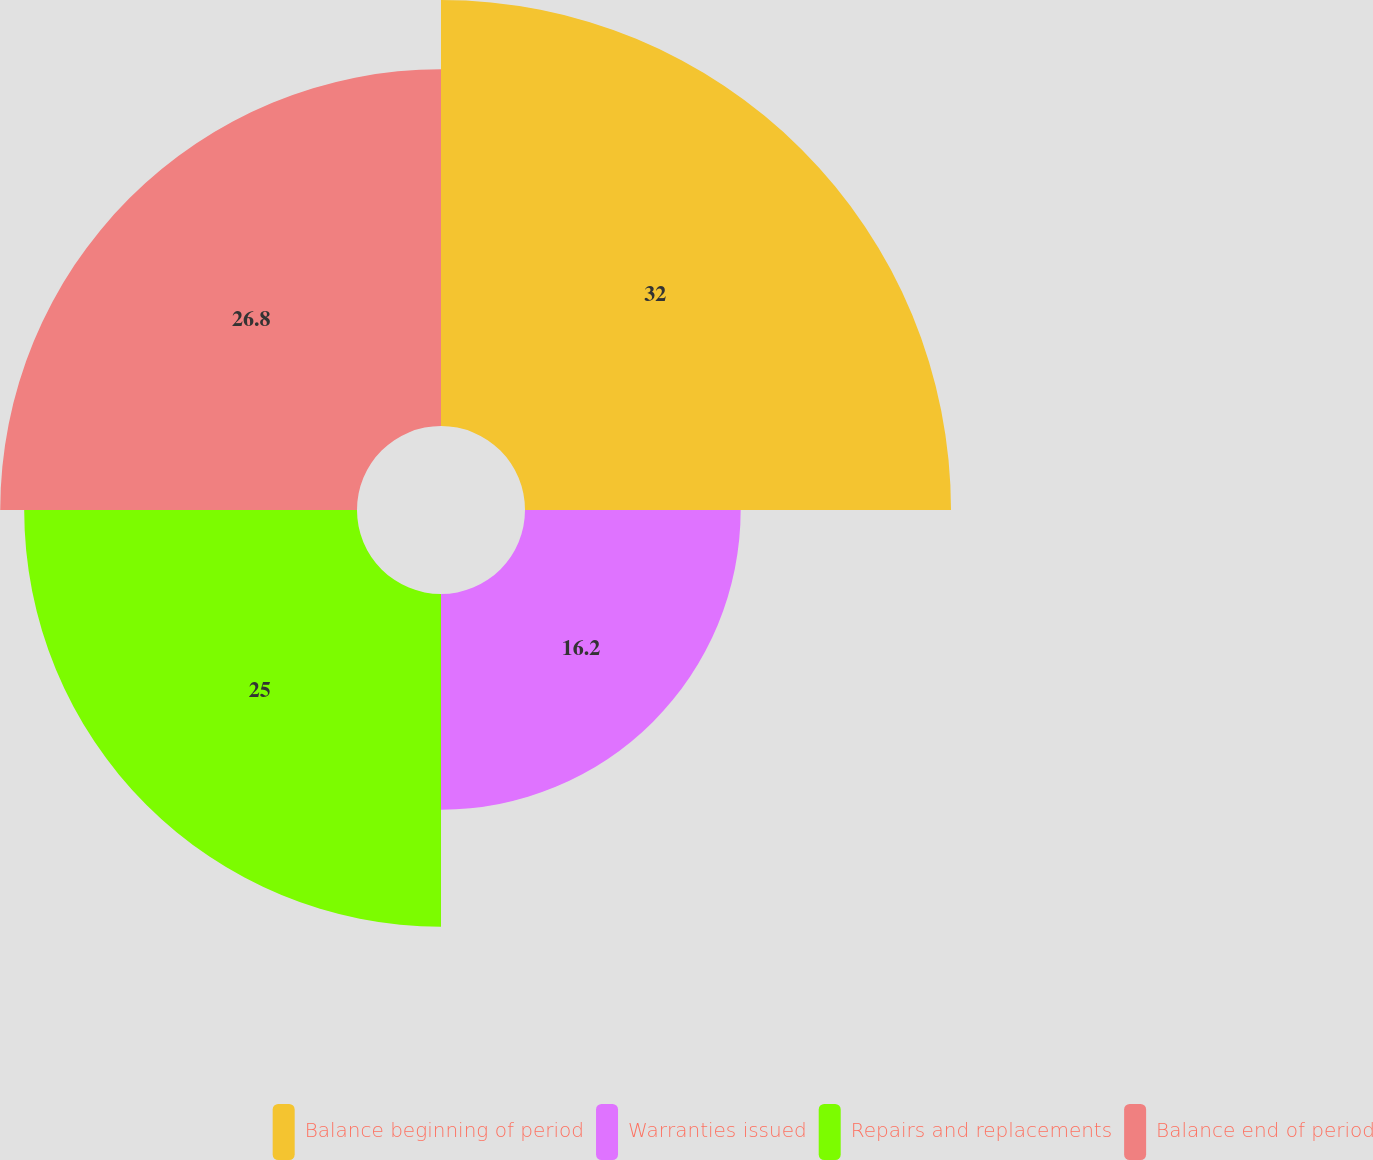<chart> <loc_0><loc_0><loc_500><loc_500><pie_chart><fcel>Balance beginning of period<fcel>Warranties issued<fcel>Repairs and replacements<fcel>Balance end of period<nl><fcel>32.0%<fcel>16.2%<fcel>25.0%<fcel>26.8%<nl></chart> 